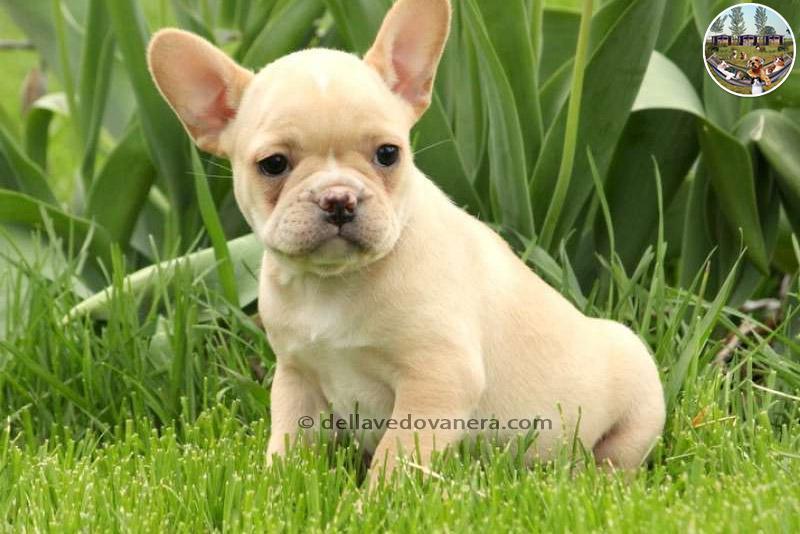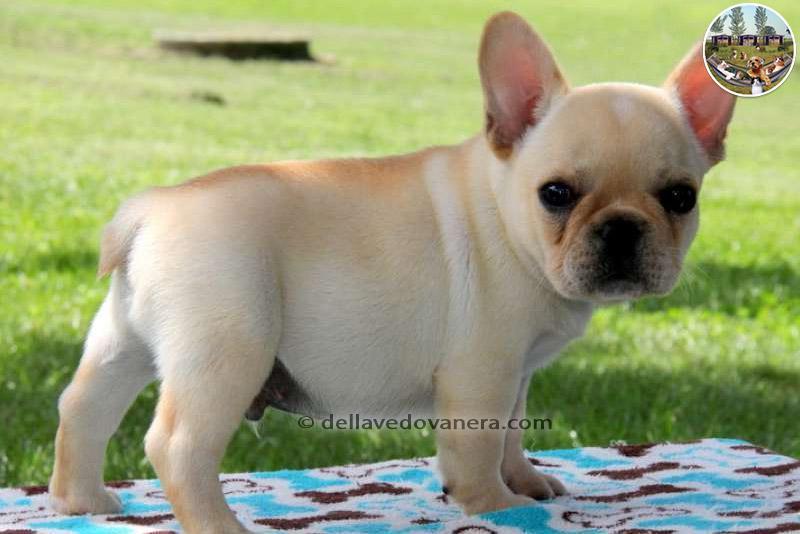The first image is the image on the left, the second image is the image on the right. Considering the images on both sides, is "No less than one dog is outside." valid? Answer yes or no. Yes. The first image is the image on the left, the second image is the image on the right. Assess this claim about the two images: "Each image contains one bulldog, and the dog on the left is standing while the dog on the right is sitting.". Correct or not? Answer yes or no. No. 